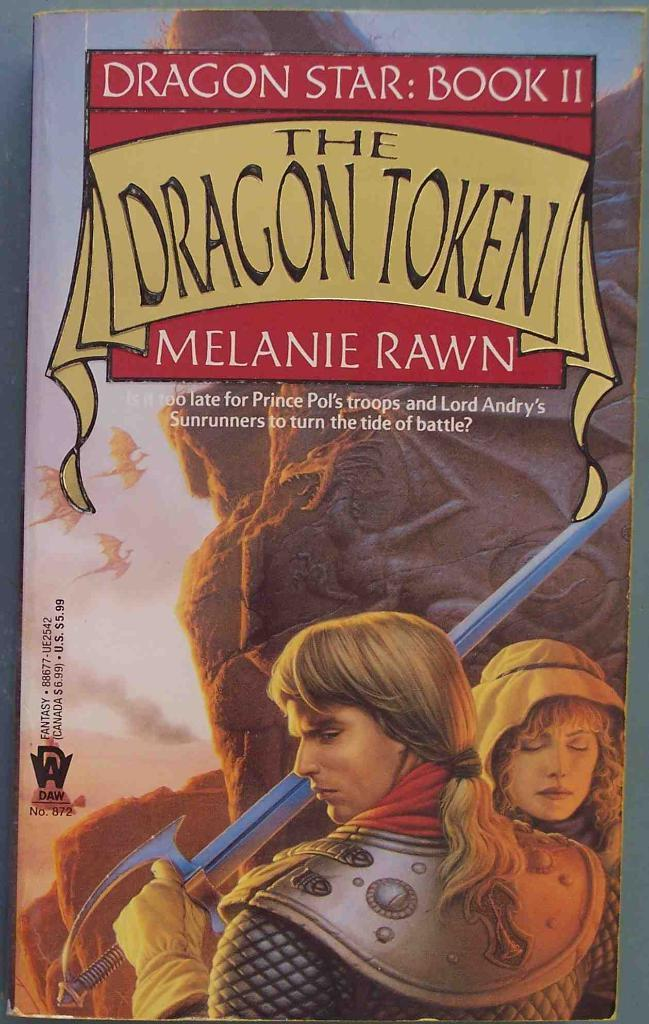What is the main object in the image? There is a poster in the image. What are the people in the image doing? People are standing on the poster. What can be seen on the poster? A man is holding a sword in his hand on the poster, and the words "THE DRAGON TOKEN" are written on the poster. What type of industry is depicted in the image? There is no industry depicted in the image; it features a poster with people standing on it and a man holding a sword. Can you explain the trick used by the man holding the sword in the image? There is no trick being performed by the man holding the sword in the image; he is simply depicted as holding a sword on the poster. 